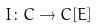<formula> <loc_0><loc_0><loc_500><loc_500>I \colon C \rightarrow C [ E ]</formula> 